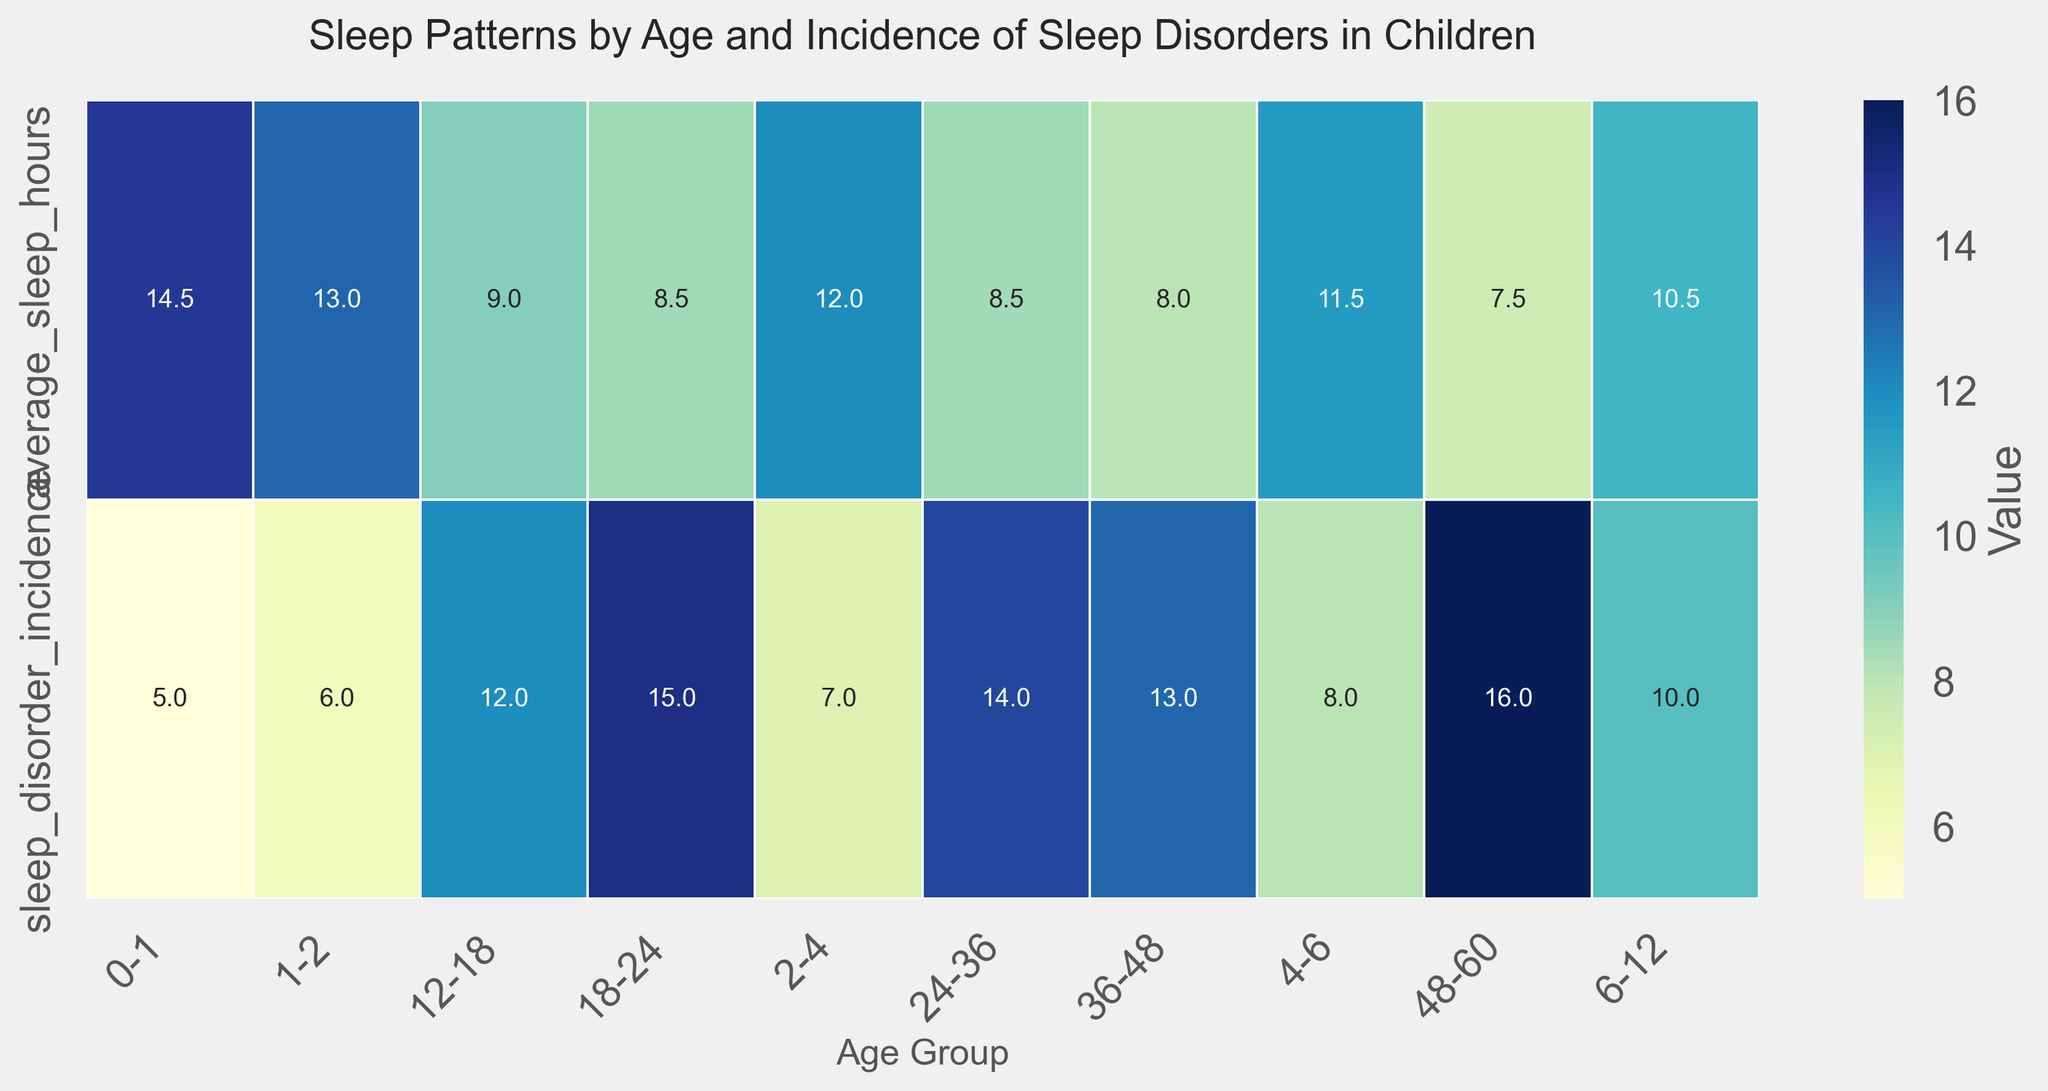How does the average sleep hours change from the 0-1 age group to the 48-60 age group? The average sleep hours for the 0-1 age group is 14.5 hours, while for the 48-60 age group, it is 7.5 hours. The change in the average sleep hours is calculated by subtracting the hours for the 48-60 age group from the 0-1 age group: 14.5 - 7.5 = 7 hours.
Answer: Decreases by 7 hours Which age group has the highest incidence of sleep disorders? The incidence of sleep disorders peaks at the age group labeled 48-60, where the value is 16.
Answer: 48-60 What is the difference in sleep disorder incidence between the age groups 1-2 and 12-18? The incidence for 1-2 years is 6 and for 12-18 years is 12. The difference is: 12 - 6 = 6.
Answer: 6 What is the average sleep disorder incidence across all age groups? The sum of sleep disorder incidences is 5 + 6 + 7 + 8 + 10 + 12 + 15 + 14 + 13 + 16 = 106. There are 10 age groups, so the average is 106 / 10 = 10.6.
Answer: 10.6 Which has a steeper decrease, the average sleep hours from age 0-1 to age 12-18, or from age 12-18 to age 48-60? From age 0-1 to 12-18, the sleep hours go from 14.5 to 9, a change of 14.5 - 9 = 5.5. From age 12-18 to 48-60, sleep hours change from 9 to 7.5, a difference of 1.5.
Answer: Age 0-1 to 12-18 Does the incidence of sleep disorders generally increase or decrease with age? A visual inspection of the heatmap shows that the incidence of sleep disorders tends to increase as the age groups progress from 0-1 to 48-60.
Answer: Increase What is the overall trend observed in average sleep hours as children age from 0-1 to 48-60? The average sleep hours decrease consistently as children age from 0-1 through 48-60 age groups, dropping from 14.5 hours to 7.5 hours.
Answer: Decrease Is there a particular age group where both the average sleep hours and sleep disorder incidence seem to change more drastically compared to other age groups? The transition from age group 4-6 to 6-12 shows a noticeable decrease in average sleep hours (from 11.5 to 10.5) and a noticeable increase in sleep disorder incidence (from 8 to 10).
Answer: 4-6 to 6-12 